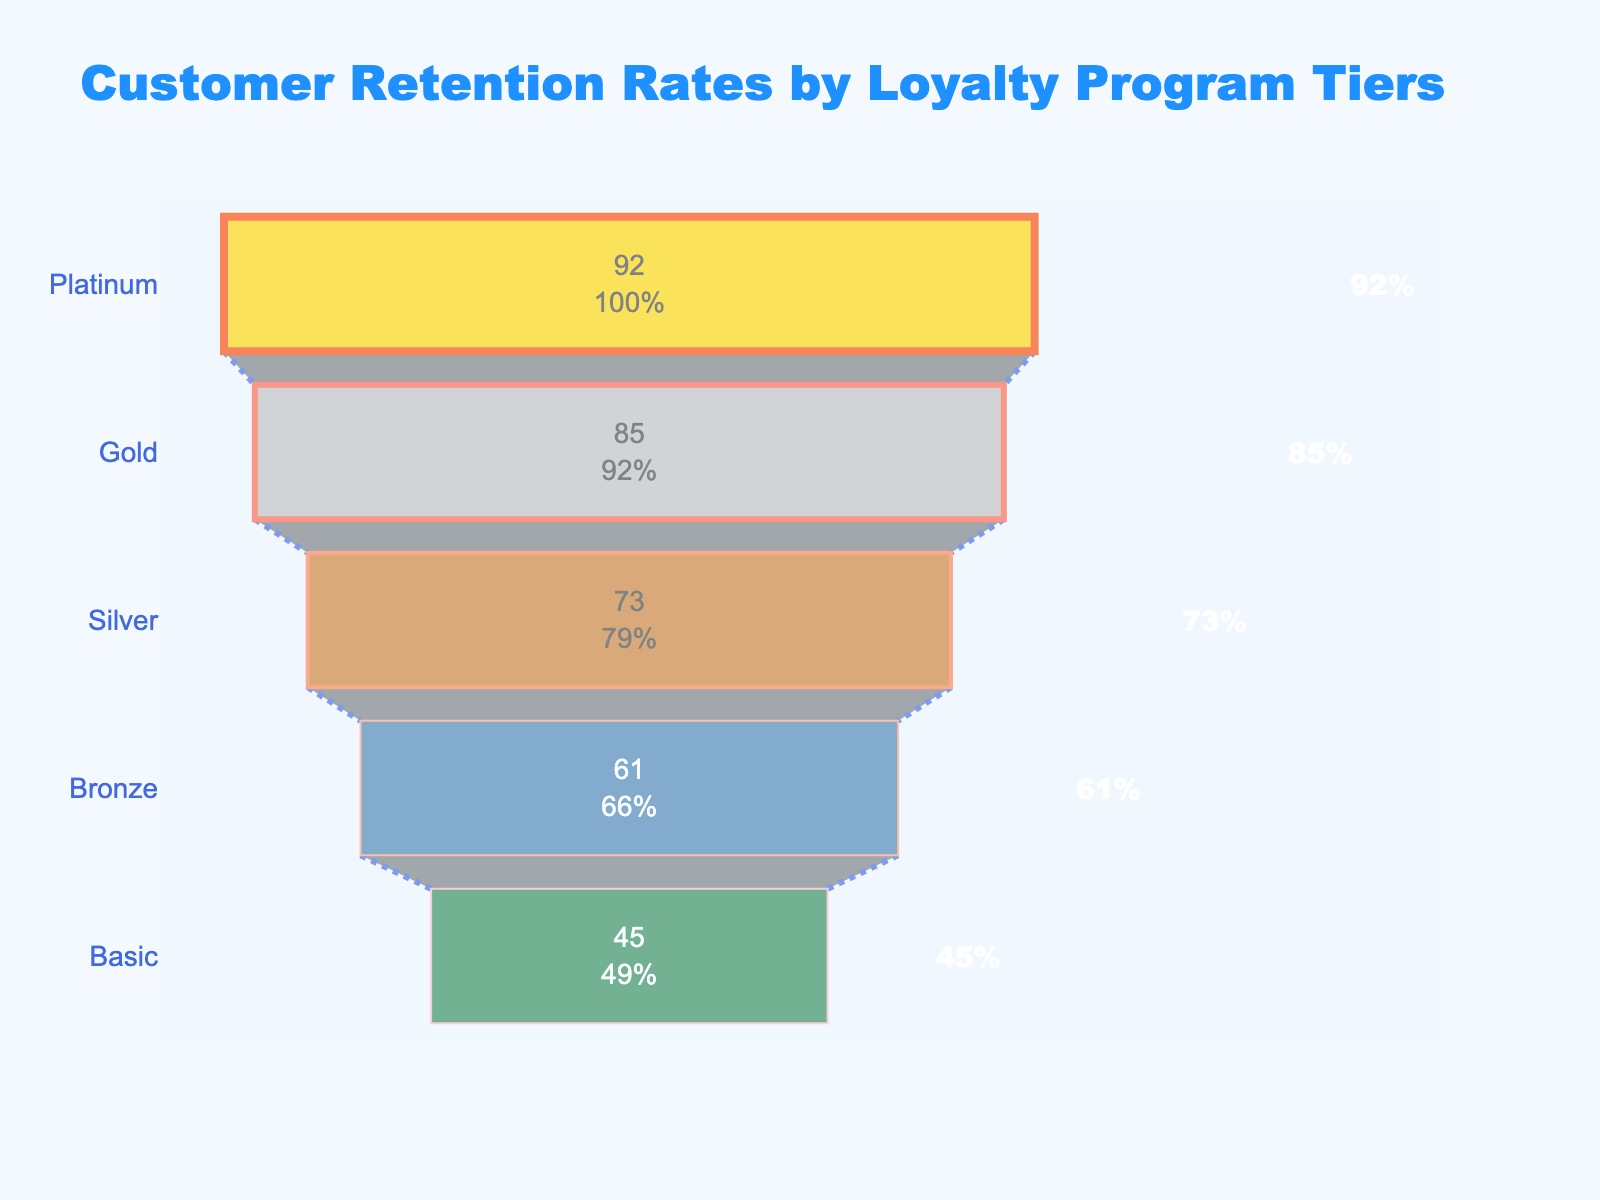What's the title of the figure? The title usually appears at the top of a figure to give a clear indication of what the figure is about. In this case, the title is "Customer Retention Rates by Loyalty Program Tiers". This helps viewers quickly understand the subject of the figure.
Answer: Customer Retention Rates by Loyalty Program Tiers How many loyalty tiers are shown in the figure? To find the number of tiers, you count the distinct categories listed in the funnel chart. Each tier represents a different level of engagement in the loyalty program. The tiers listed are Platinum, Gold, Silver, Bronze, and Basic.
Answer: 5 Which tier has the highest retention rate? To determine the tier with the highest retention rate, look at the top of the funnel where the widest section is located. This section represents the highest retention rate, which corresponds to the Platinum tier with a rate of 92%.
Answer: Platinum What is the retention rate for the Basic tier? The retention rate for the Basic tier can be found at the bottom of the funnel chart, where it is specified within the section labeled "Basic". According to the figure, the retention rate for Basic is 45%.
Answer: 45% How much higher is the retention rate for the Platinum tier compared to the Gold tier? To calculate the difference in retention rates between the Platinum and Gold tiers, subtract the retention rate of the Gold tier from that of the Platinum tier. Platinum has a retention rate of 92%, and Gold has a retention rate of 85%. The difference is 92% - 85% = 7%.
Answer: 7% Which tier has a lower retention rate: Silver or Bronze? By comparing the retention rates of the Silver and Bronze tiers, find that the Silver tier has a retention rate of 73%, while the Bronze tier has a lower retention rate of 61%.
Answer: Bronze What is the average retention rate across all tiers? To determine the average retention rate, sum the retention rates of all the tiers and divide by the number of tiers. The retention rates are 92 (Platinum), 85 (Gold), 73 (Silver), 61 (Bronze), and 45 (Basic). The sum is 356, and dividing by 5 gives an average of 71.2.
Answer: 71.2 What's the difference in retention rates between the highest and lowest tiers? To find the difference between the highest and lowest retention rates, subtract the retention rate of the Basic tier (45%) from that of the Platinum tier (92%). The difference is 92% - 45% = 47%.
Answer: 47% What percentage of the initial customers does the Gold tier retain? The retention rate for the Gold tier specifies the percentage of initial customers retained. According to the figure, the Gold tier retains 85% of its initial customers.
Answer: 85% Which tier has the second highest retention rate, and what is it? The second highest retention rate is found just below the highest (Platinum) in the funnel chart. The Gold tier has the second highest retention rate, which is 85%.
Answer: Gold, 85% 